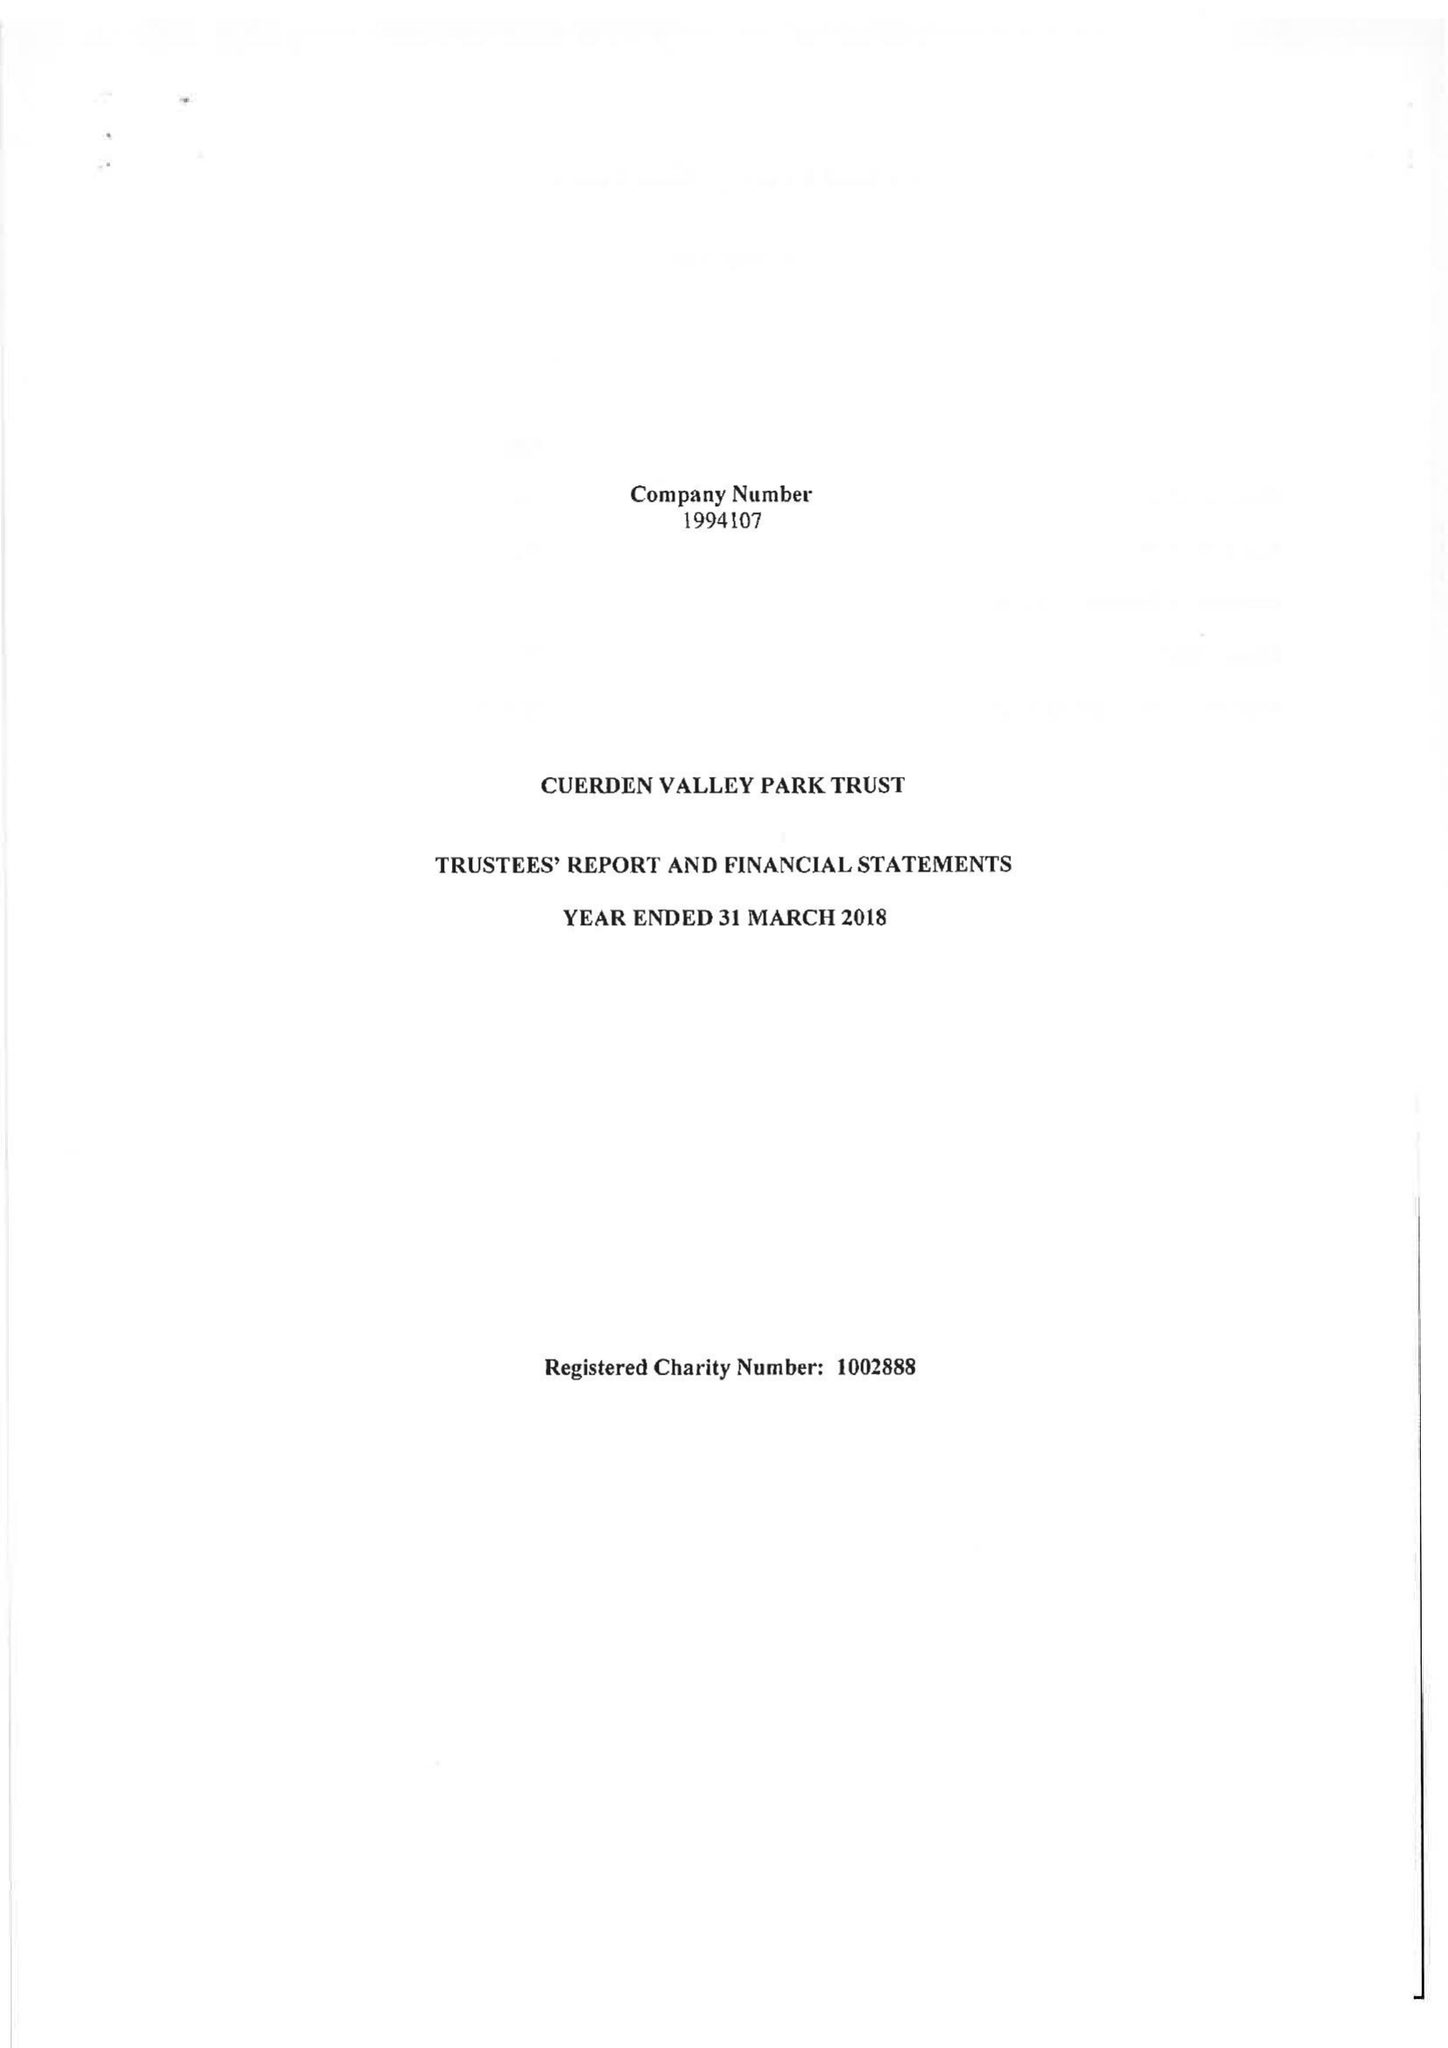What is the value for the income_annually_in_british_pounds?
Answer the question using a single word or phrase. 260143.00 